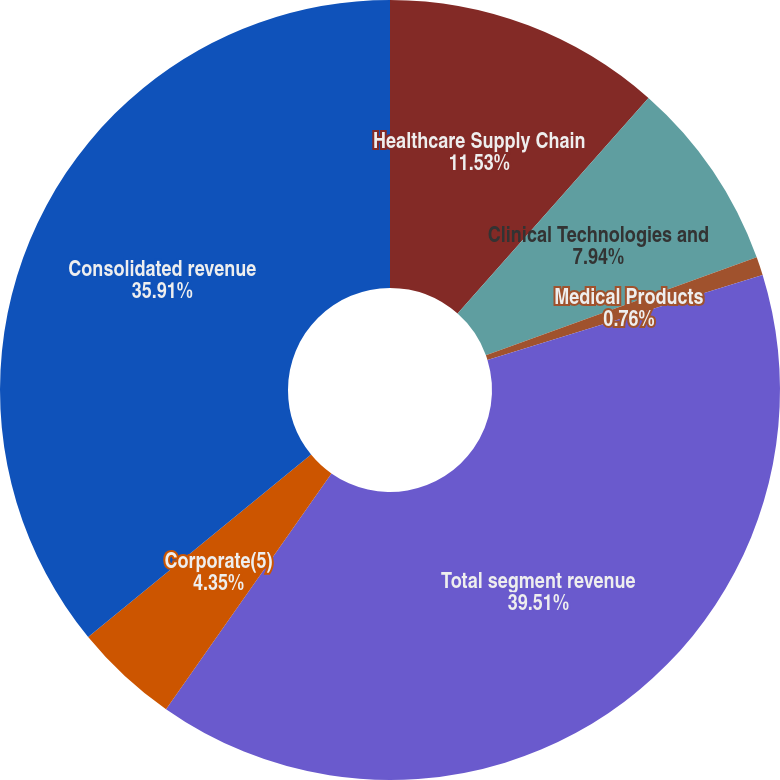Convert chart to OTSL. <chart><loc_0><loc_0><loc_500><loc_500><pie_chart><fcel>Healthcare Supply Chain<fcel>Clinical Technologies and<fcel>Medical Products<fcel>Total segment revenue<fcel>Corporate(5)<fcel>Consolidated revenue<nl><fcel>11.53%<fcel>7.94%<fcel>0.76%<fcel>39.5%<fcel>4.35%<fcel>35.91%<nl></chart> 